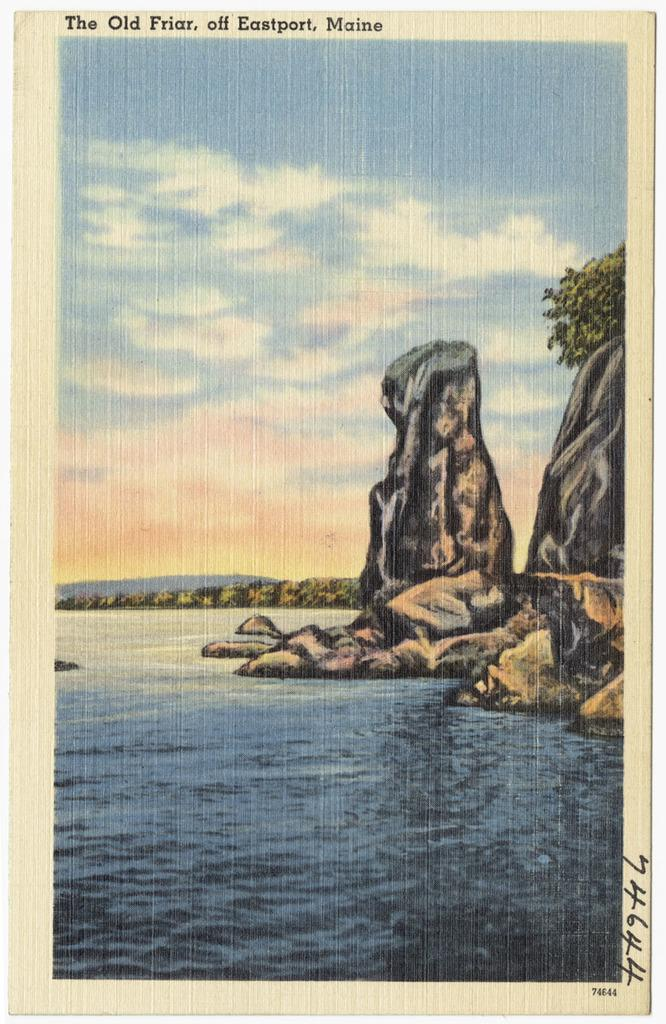What is on the paper in the image? The paper contains a painting. What is depicted in the painting? The painting depicts water, rocks, and the sky. What is the condition of the sky in the painting? The sky in the painting has clouds. Is there any text on the paper? Yes, there is writing on the top of the paper and in the right bottom corner of the paper. What type of potato is being used as a police officer in the painting? There is no potato or police officer depicted in the painting; it features a landscape with water, rocks, and a cloudy sky. 